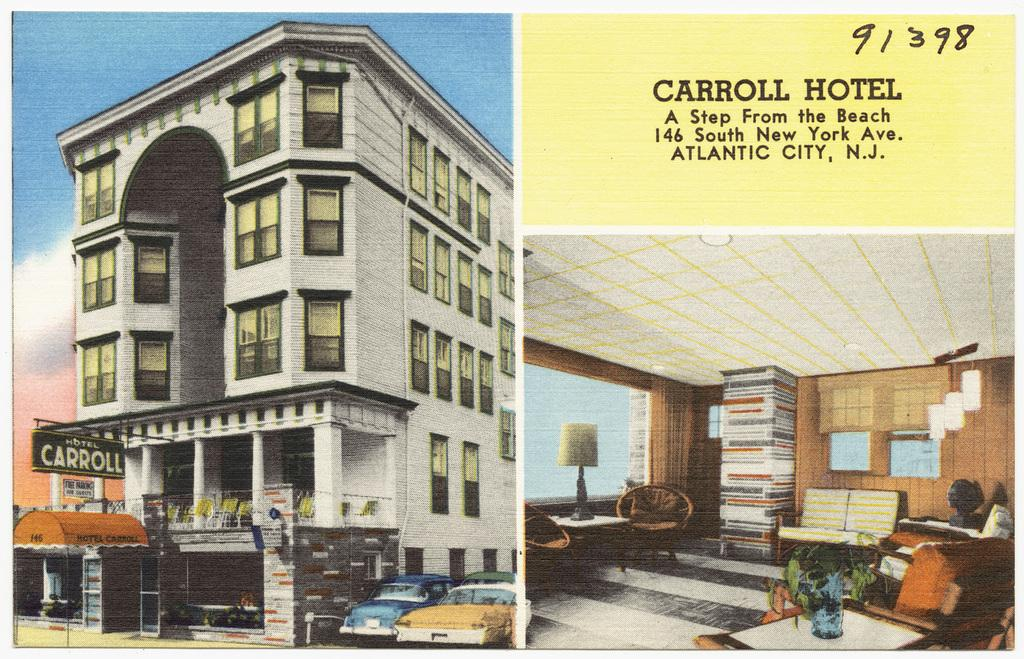<image>
Share a concise interpretation of the image provided. A postcard of some pictures of the Carroll Hotel 